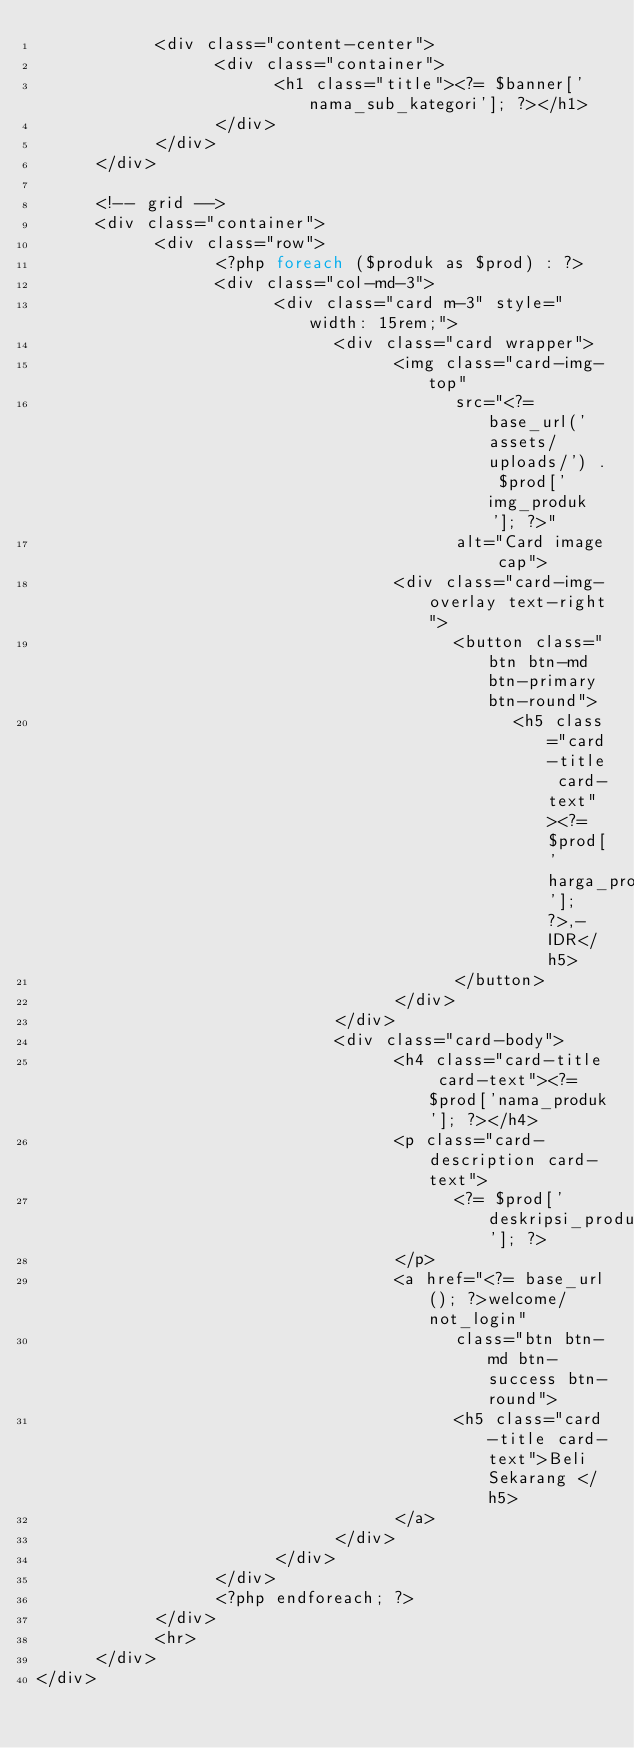Convert code to text. <code><loc_0><loc_0><loc_500><loc_500><_PHP_>            <div class="content-center">
                  <div class="container">
                        <h1 class="title"><?= $banner['nama_sub_kategori']; ?></h1>
                  </div>
            </div>
      </div>

      <!-- grid -->
      <div class="container">
            <div class="row">
                  <?php foreach ($produk as $prod) : ?>
                  <div class="col-md-3">
                        <div class="card m-3" style="width: 15rem;">
                              <div class="card wrapper">
                                    <img class="card-img-top"
                                          src="<?= base_url('assets/uploads/') . $prod['img_produk']; ?>"
                                          alt="Card image cap">
                                    <div class="card-img-overlay text-right">
                                          <button class="btn btn-md btn-primary btn-round">
                                                <h5 class="card-title card-text"><?= $prod['harga_produk']; ?>,-IDR</h5>
                                          </button>
                                    </div>
                              </div>
                              <div class="card-body">
                                    <h4 class="card-title card-text"><?= $prod['nama_produk']; ?></h4>
                                    <p class="card-description card-text">
                                          <?= $prod['deskripsi_produk']; ?>
                                    </p>
                                    <a href="<?= base_url(); ?>welcome/not_login"
                                          class="btn btn-md btn-success btn-round">
                                          <h5 class="card-title card-text">Beli Sekarang </h5>
                                    </a>
                              </div>
                        </div>
                  </div>
                  <?php endforeach; ?>
            </div>
            <hr>
      </div>
</div></code> 